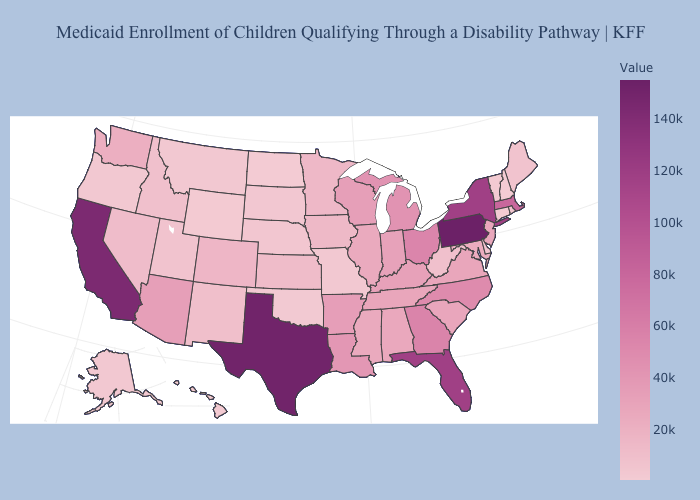Does Connecticut have the lowest value in the USA?
Write a very short answer. Yes. Does Vermont have the highest value in the USA?
Write a very short answer. No. Which states have the lowest value in the South?
Quick response, please. Oklahoma. Does the map have missing data?
Short answer required. No. Does Alaska have the lowest value in the West?
Concise answer only. No. Among the states that border Washington , which have the lowest value?
Be succinct. Oregon. Which states hav the highest value in the Northeast?
Short answer required. Pennsylvania. 